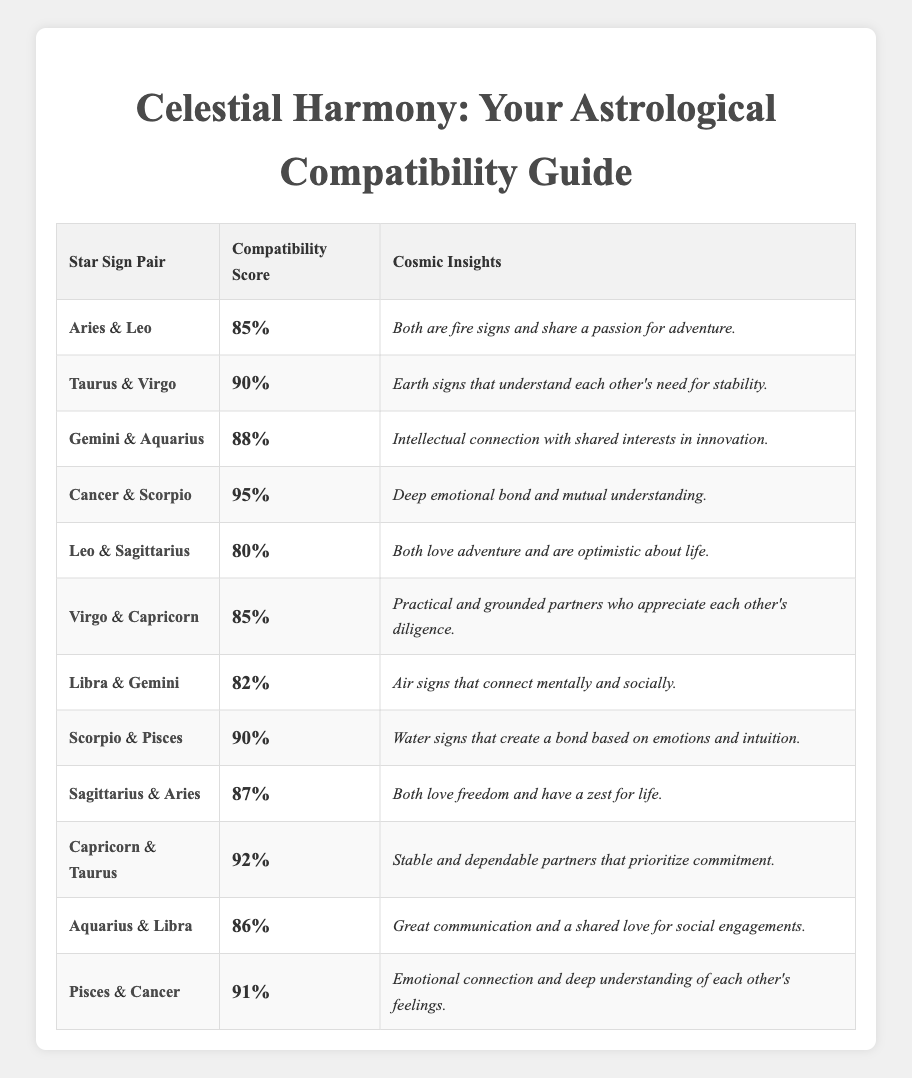What's the compatibility score between Cancer and Scorpio? The table shows that the compatibility score for the pair Cancer and Scorpio is listed directly in the corresponding row, which is 95.
Answer: 95 Which star sign pair has the highest compatibility score? By scanning the compatibility scores for all the pairs, Cancer and Scorpio have the highest score of 95, which is the maximum value in the table.
Answer: Cancer and Scorpio Is Taurus compatible with Libra based on the scores? Taurus does not appear paired with Libra in the table, so there is no compatibility score provided for that pairing. Therefore, we cannot verify compatibility based on the table.
Answer: No What is the average compatibility score of Air signs (Gemini, Libra, and Aquarius)? First, extract the scores: Gemini & Aquarius = 88, Libra & Gemini = 82, Aquarius & Libra = 86. Then, sum them up: 88 + 82 + 86 = 256. There are 3 pairs, so the average score is 256 / 3 = 85.33.
Answer: 85.33 Are all pairs sharing the same element rated favorably? Review the scores for pairs sharing the same element: Fire signs (Aries & Leo = 85, Leo & Sagittarius = 80), Earth signs (Taurus & Virgo = 90, Virgo & Capricorn = 85, Capricorn & Taurus = 92), Air signs (Libra & Gemini = 82, Aquarius & Libra = 86), and Water signs (Cancer & Scorpio = 95, Scorpio & Pisces = 90, Pisces & Cancer = 91). Most are positively rated, indicating general favorability, except Leo & Sagittarius at 80.
Answer: No Which two signs have the lowest compatibility score, and what is it? Inspecting the table for the lowest score, Leo & Sagittarius have the lowest compatibility score of 80 among all pairs.
Answer: 80 (Leo & Sagittarius) What common trait is shared by Scorpio and Pisces? The description for Scorpio and Pisces states they both create a bond based on emotions and intuition, indicating a shared common trait.
Answer: Emotional connection Which pair of signs has a compatibility score that is higher than 85 but lower than 90? From the compatibility scores, Taurus & Virgo (90) and Capricorn & Taurus (92) are above 85; Gemini & Aquarius (88) fits the criteria as it is above 85 but less than 90.
Answer: Gemini & Aquarius Is the compatibility score for Aries and Leo greater than that of Virgo and Capricorn? Comparing the scores from the table: Aries & Leo = 85 and Virgo & Capricorn = 85. Since they are equal and not greater, the answer is no.
Answer: No What pattern can be observed among the pairs with water signs? The compatibility scores for water signs (Cancer & Scorpio = 95, Scorpio & Pisces = 90, Pisces & Cancer = 91) indicate a strong emotional bond and high scores across all pairs. This pattern shows water signs tend to have very high compatibility levels with each other.
Answer: Strong emotional bonds Which pairs share a score of at least 90? The pairs with scores of at least 90 are Taurus & Virgo (90), Scorpio & Pisces (90), Capricorn & Taurus (92), and Cancer & Scorpio (95).
Answer: Taurus & Virgo, Scorpio & Pisces, Capricorn & Taurus, Cancer & Scorpio 